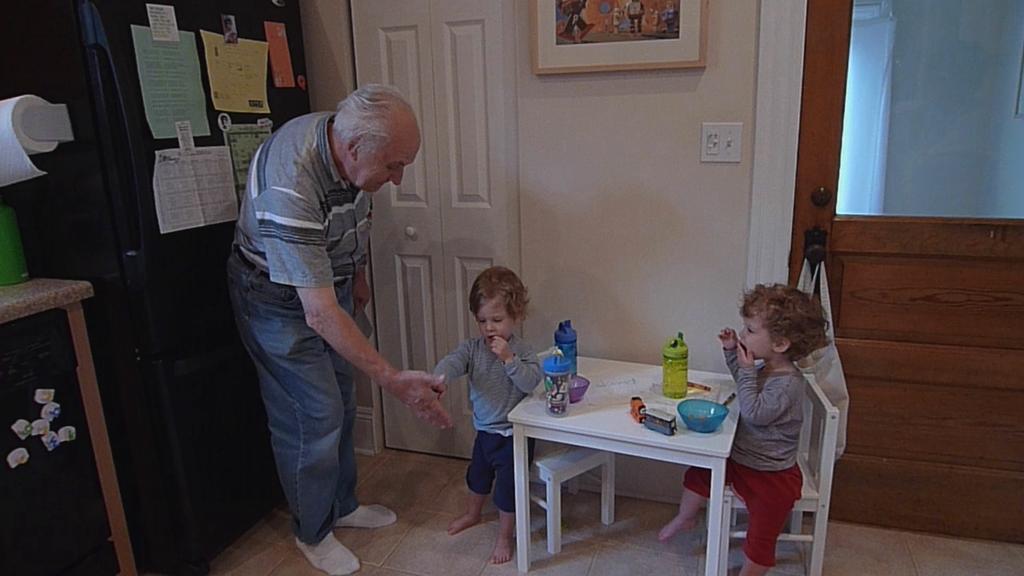Can you describe this image briefly? As we can see in the image there is a wall, door, a man standing over here and there is a table. On table there is a boil, bottles and on the left side there a almara. 